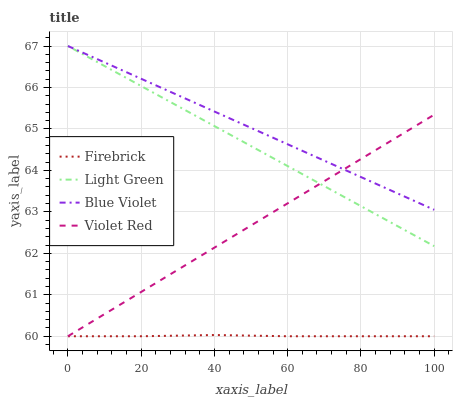Does Firebrick have the minimum area under the curve?
Answer yes or no. Yes. Does Blue Violet have the maximum area under the curve?
Answer yes or no. Yes. Does Blue Violet have the minimum area under the curve?
Answer yes or no. No. Does Firebrick have the maximum area under the curve?
Answer yes or no. No. Is Violet Red the smoothest?
Answer yes or no. Yes. Is Firebrick the roughest?
Answer yes or no. Yes. Is Blue Violet the smoothest?
Answer yes or no. No. Is Blue Violet the roughest?
Answer yes or no. No. Does Violet Red have the lowest value?
Answer yes or no. Yes. Does Blue Violet have the lowest value?
Answer yes or no. No. Does Light Green have the highest value?
Answer yes or no. Yes. Does Firebrick have the highest value?
Answer yes or no. No. Is Firebrick less than Blue Violet?
Answer yes or no. Yes. Is Light Green greater than Firebrick?
Answer yes or no. Yes. Does Light Green intersect Blue Violet?
Answer yes or no. Yes. Is Light Green less than Blue Violet?
Answer yes or no. No. Is Light Green greater than Blue Violet?
Answer yes or no. No. Does Firebrick intersect Blue Violet?
Answer yes or no. No. 